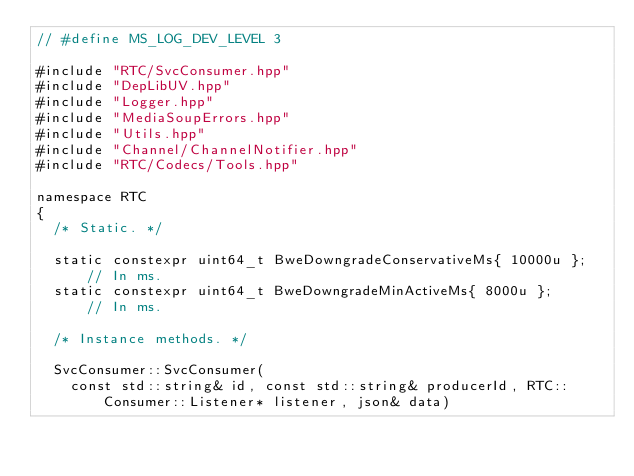Convert code to text. <code><loc_0><loc_0><loc_500><loc_500><_C++_>// #define MS_LOG_DEV_LEVEL 3

#include "RTC/SvcConsumer.hpp"
#include "DepLibUV.hpp"
#include "Logger.hpp"
#include "MediaSoupErrors.hpp"
#include "Utils.hpp"
#include "Channel/ChannelNotifier.hpp"
#include "RTC/Codecs/Tools.hpp"

namespace RTC
{
	/* Static. */

	static constexpr uint64_t BweDowngradeConservativeMs{ 10000u }; // In ms.
	static constexpr uint64_t BweDowngradeMinActiveMs{ 8000u };     // In ms.

	/* Instance methods. */

	SvcConsumer::SvcConsumer(
	  const std::string& id, const std::string& producerId, RTC::Consumer::Listener* listener, json& data)</code> 